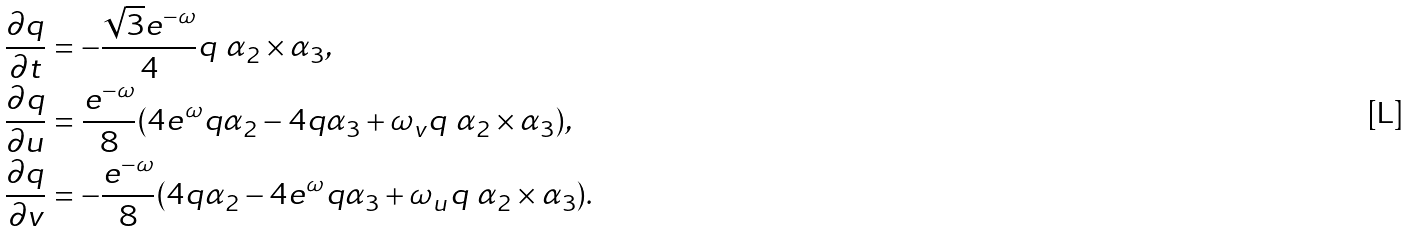Convert formula to latex. <formula><loc_0><loc_0><loc_500><loc_500>& \frac { \partial q } { \partial t } = - \frac { \sqrt { 3 } e ^ { - \omega } } { 4 } q \ \alpha _ { 2 } \times \alpha _ { 3 } , \\ & \frac { \partial q } { \partial u } = \frac { e ^ { - \omega } } { 8 } ( 4 e ^ { \omega } q \alpha _ { 2 } - 4 q \alpha _ { 3 } + \omega _ { v } q \ \alpha _ { 2 } \times \alpha _ { 3 } ) , \\ & \frac { \partial q } { \partial v } = - \frac { e ^ { - \omega } } { 8 } ( 4 q \alpha _ { 2 } - 4 e ^ { \omega } q \alpha _ { 3 } + \omega _ { u } q \ \alpha _ { 2 } \times \alpha _ { 3 } ) .</formula> 